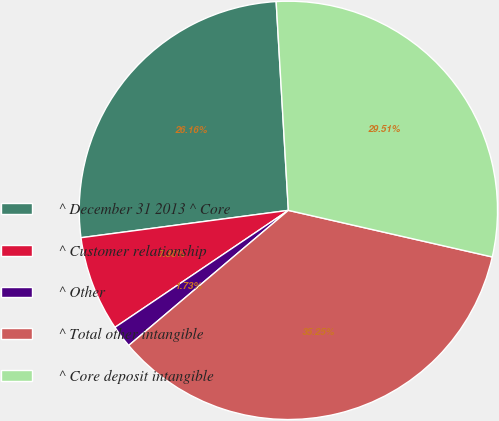<chart> <loc_0><loc_0><loc_500><loc_500><pie_chart><fcel>^ December 31 2013 ^ Core<fcel>^ Customer relationship<fcel>^ Other<fcel>^ Total other intangible<fcel>^ Core deposit intangible<nl><fcel>26.16%<fcel>7.36%<fcel>1.73%<fcel>35.25%<fcel>29.51%<nl></chart> 